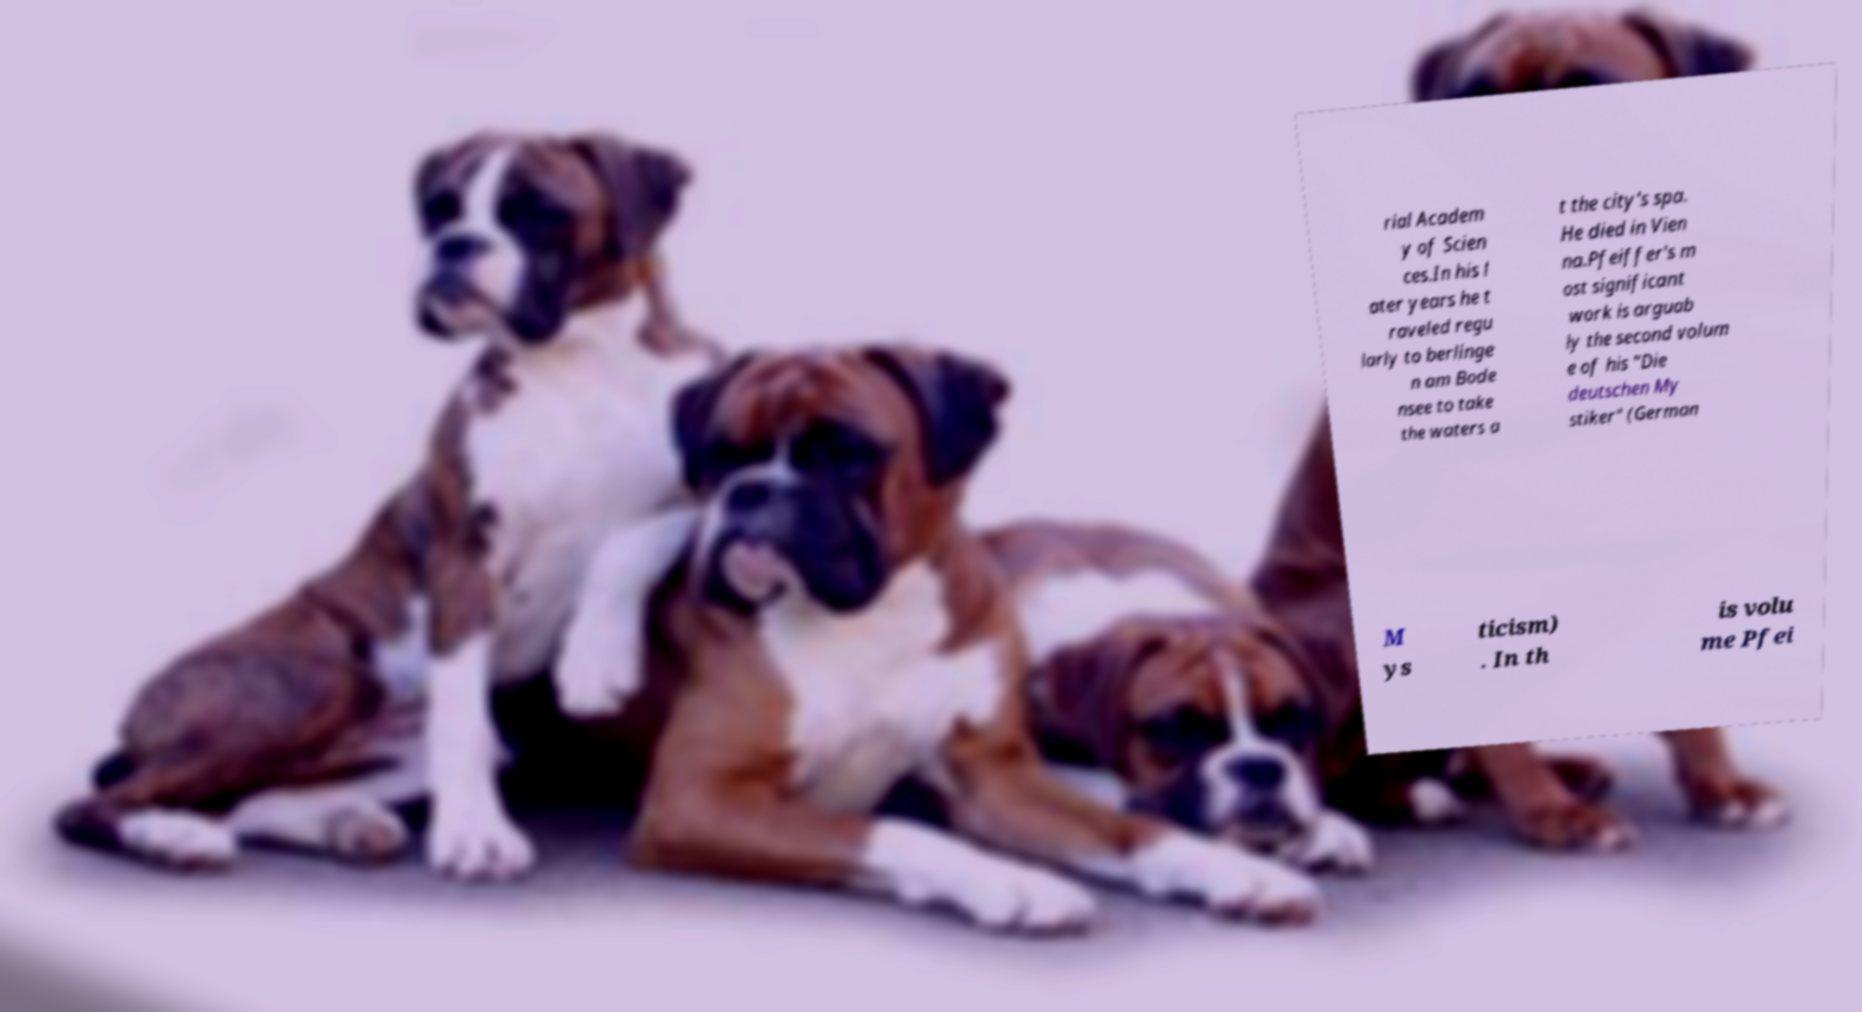Can you read and provide the text displayed in the image?This photo seems to have some interesting text. Can you extract and type it out for me? rial Academ y of Scien ces.In his l ater years he t raveled regu larly to berlinge n am Bode nsee to take the waters a t the city's spa. He died in Vien na.Pfeiffer's m ost significant work is arguab ly the second volum e of his "Die deutschen My stiker" (German M ys ticism) . In th is volu me Pfei 